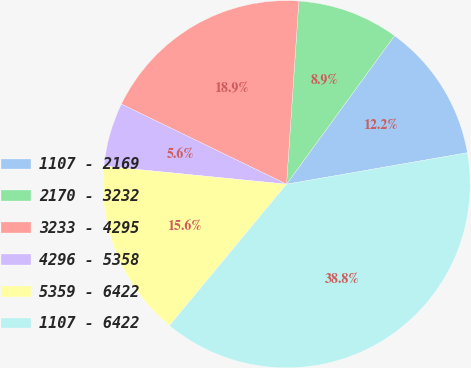Convert chart. <chart><loc_0><loc_0><loc_500><loc_500><pie_chart><fcel>1107 - 2169<fcel>2170 - 3232<fcel>3233 - 4295<fcel>4296 - 5358<fcel>5359 - 6422<fcel>1107 - 6422<nl><fcel>12.25%<fcel>8.94%<fcel>18.88%<fcel>5.62%<fcel>15.56%<fcel>38.75%<nl></chart> 